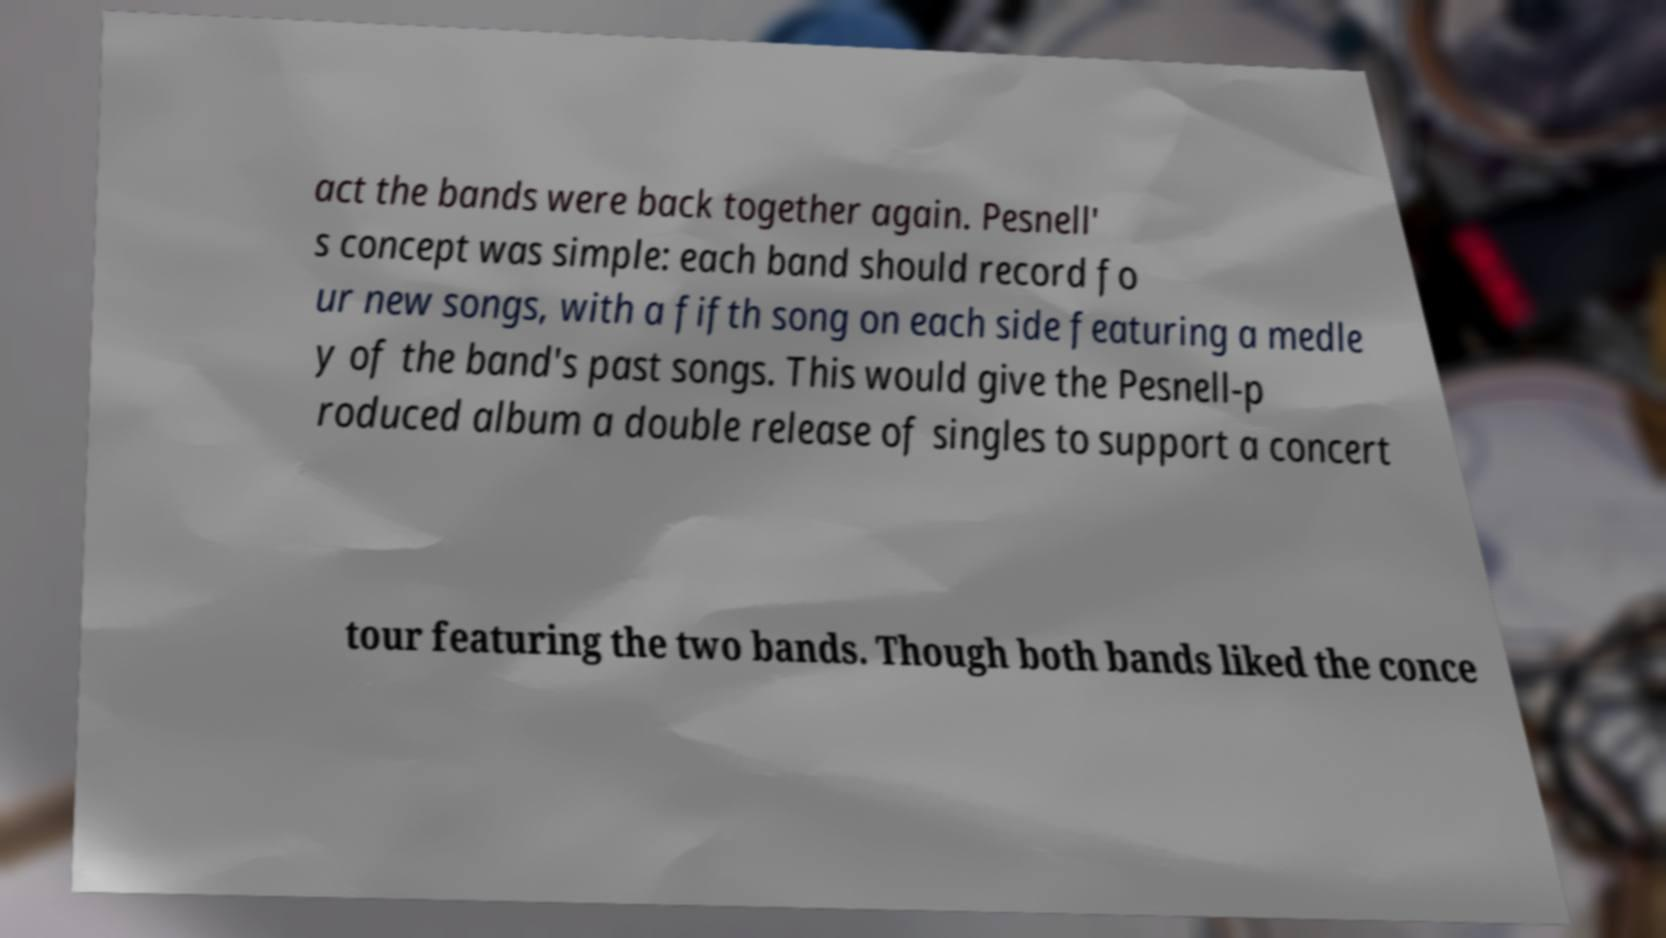There's text embedded in this image that I need extracted. Can you transcribe it verbatim? act the bands were back together again. Pesnell' s concept was simple: each band should record fo ur new songs, with a fifth song on each side featuring a medle y of the band's past songs. This would give the Pesnell-p roduced album a double release of singles to support a concert tour featuring the two bands. Though both bands liked the conce 